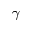<formula> <loc_0><loc_0><loc_500><loc_500>\gamma</formula> 